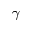<formula> <loc_0><loc_0><loc_500><loc_500>\gamma</formula> 